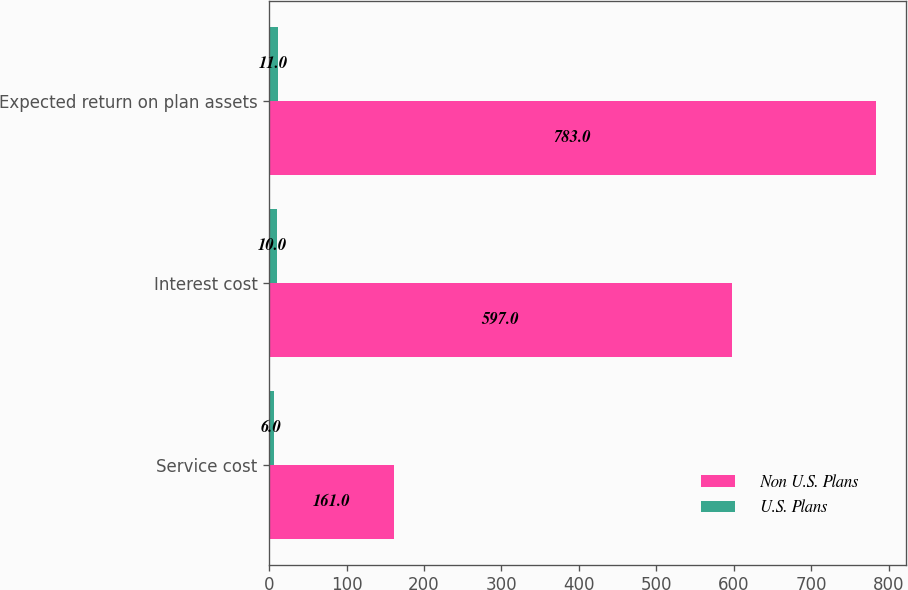<chart> <loc_0><loc_0><loc_500><loc_500><stacked_bar_chart><ecel><fcel>Service cost<fcel>Interest cost<fcel>Expected return on plan assets<nl><fcel>Non U.S. Plans<fcel>161<fcel>597<fcel>783<nl><fcel>U.S. Plans<fcel>6<fcel>10<fcel>11<nl></chart> 